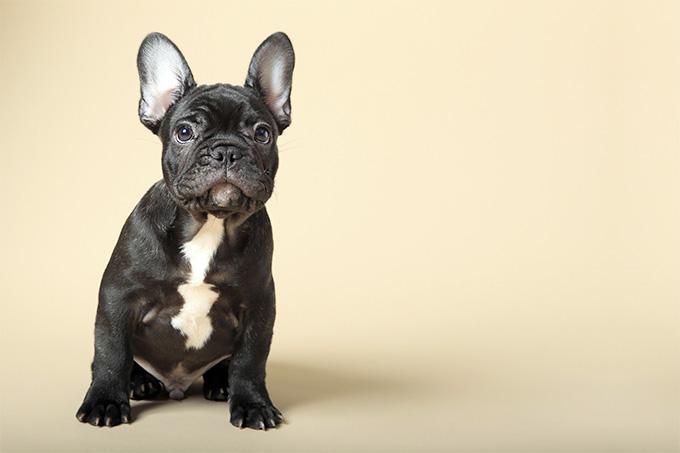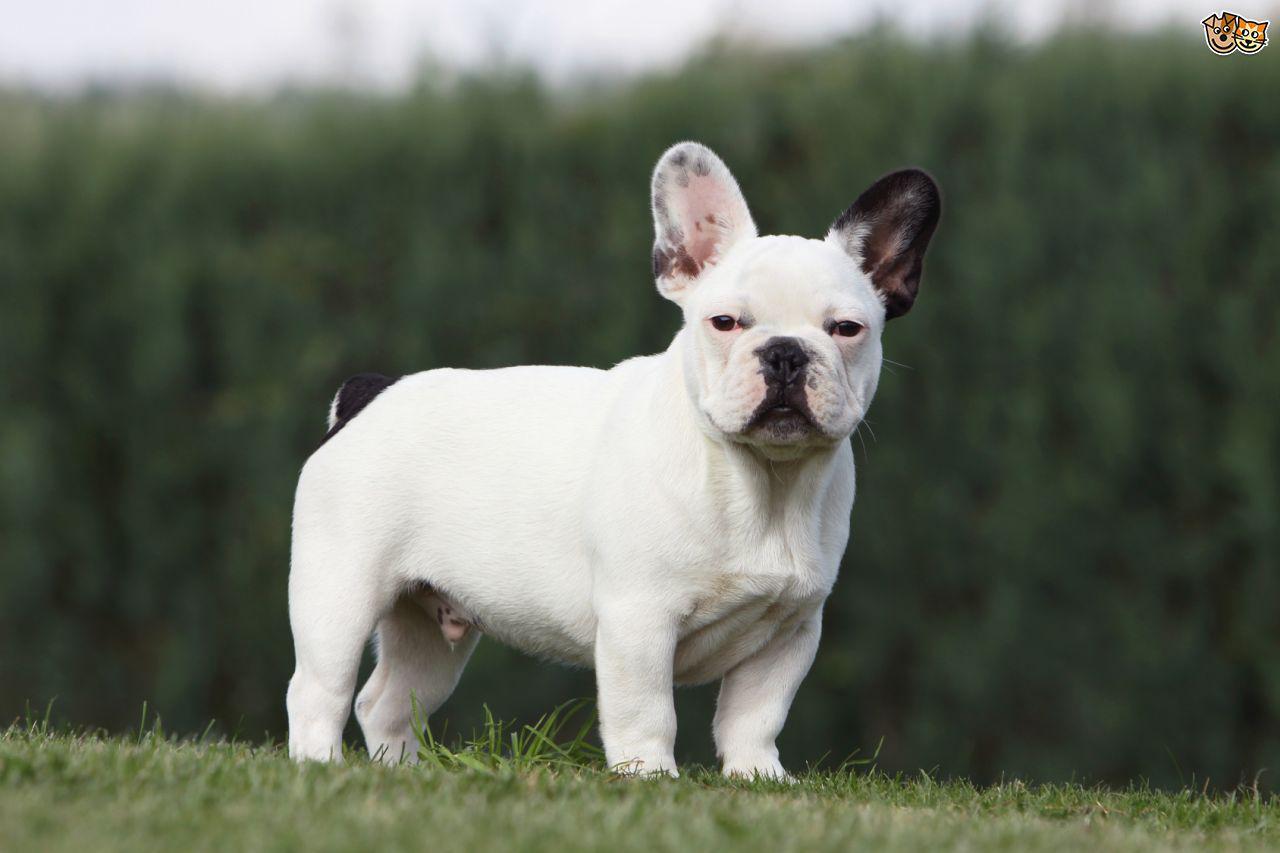The first image is the image on the left, the second image is the image on the right. Given the left and right images, does the statement "Two small dogs with ears standing up have no collar or leash." hold true? Answer yes or no. Yes. 